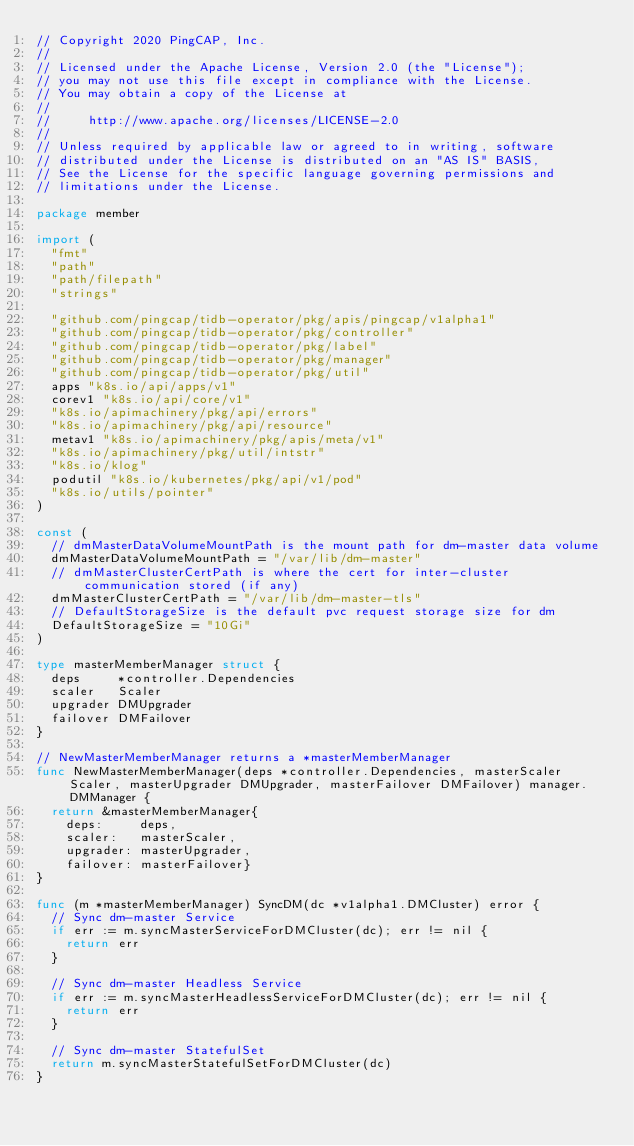<code> <loc_0><loc_0><loc_500><loc_500><_Go_>// Copyright 2020 PingCAP, Inc.
//
// Licensed under the Apache License, Version 2.0 (the "License");
// you may not use this file except in compliance with the License.
// You may obtain a copy of the License at
//
//     http://www.apache.org/licenses/LICENSE-2.0
//
// Unless required by applicable law or agreed to in writing, software
// distributed under the License is distributed on an "AS IS" BASIS,
// See the License for the specific language governing permissions and
// limitations under the License.

package member

import (
	"fmt"
	"path"
	"path/filepath"
	"strings"

	"github.com/pingcap/tidb-operator/pkg/apis/pingcap/v1alpha1"
	"github.com/pingcap/tidb-operator/pkg/controller"
	"github.com/pingcap/tidb-operator/pkg/label"
	"github.com/pingcap/tidb-operator/pkg/manager"
	"github.com/pingcap/tidb-operator/pkg/util"
	apps "k8s.io/api/apps/v1"
	corev1 "k8s.io/api/core/v1"
	"k8s.io/apimachinery/pkg/api/errors"
	"k8s.io/apimachinery/pkg/api/resource"
	metav1 "k8s.io/apimachinery/pkg/apis/meta/v1"
	"k8s.io/apimachinery/pkg/util/intstr"
	"k8s.io/klog"
	podutil "k8s.io/kubernetes/pkg/api/v1/pod"
	"k8s.io/utils/pointer"
)

const (
	// dmMasterDataVolumeMountPath is the mount path for dm-master data volume
	dmMasterDataVolumeMountPath = "/var/lib/dm-master"
	// dmMasterClusterCertPath is where the cert for inter-cluster communication stored (if any)
	dmMasterClusterCertPath = "/var/lib/dm-master-tls"
	// DefaultStorageSize is the default pvc request storage size for dm
	DefaultStorageSize = "10Gi"
)

type masterMemberManager struct {
	deps     *controller.Dependencies
	scaler   Scaler
	upgrader DMUpgrader
	failover DMFailover
}

// NewMasterMemberManager returns a *masterMemberManager
func NewMasterMemberManager(deps *controller.Dependencies, masterScaler Scaler, masterUpgrader DMUpgrader, masterFailover DMFailover) manager.DMManager {
	return &masterMemberManager{
		deps:     deps,
		scaler:   masterScaler,
		upgrader: masterUpgrader,
		failover: masterFailover}
}

func (m *masterMemberManager) SyncDM(dc *v1alpha1.DMCluster) error {
	// Sync dm-master Service
	if err := m.syncMasterServiceForDMCluster(dc); err != nil {
		return err
	}

	// Sync dm-master Headless Service
	if err := m.syncMasterHeadlessServiceForDMCluster(dc); err != nil {
		return err
	}

	// Sync dm-master StatefulSet
	return m.syncMasterStatefulSetForDMCluster(dc)
}
</code> 